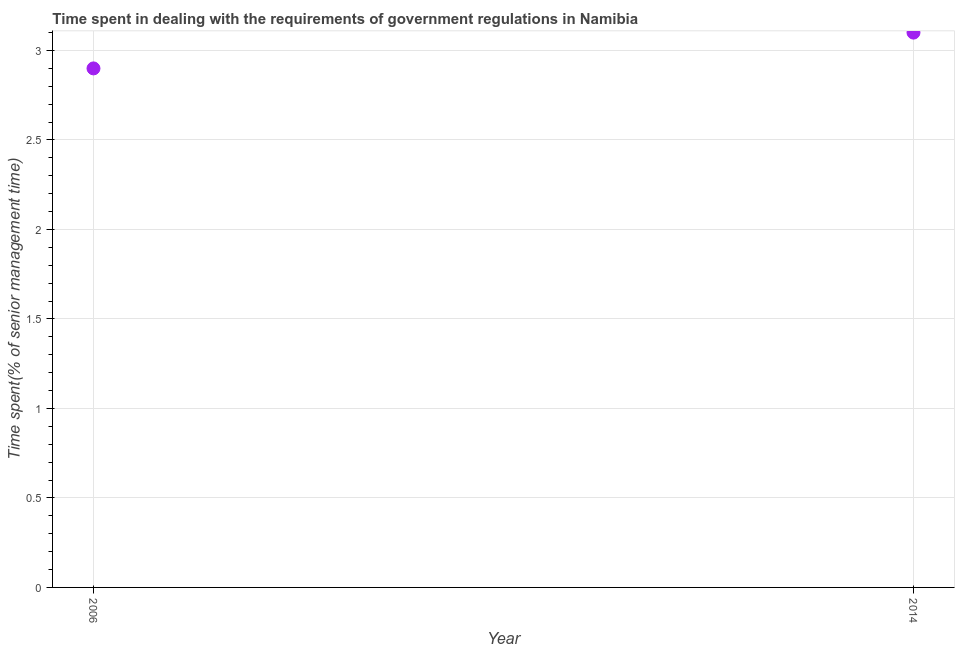What is the time spent in dealing with government regulations in 2014?
Provide a short and direct response. 3.1. In which year was the time spent in dealing with government regulations maximum?
Make the answer very short. 2014. What is the sum of the time spent in dealing with government regulations?
Provide a short and direct response. 6. What is the difference between the time spent in dealing with government regulations in 2006 and 2014?
Your answer should be very brief. -0.2. What is the median time spent in dealing with government regulations?
Offer a terse response. 3. Do a majority of the years between 2006 and 2014 (inclusive) have time spent in dealing with government regulations greater than 1.2 %?
Your answer should be compact. Yes. What is the ratio of the time spent in dealing with government regulations in 2006 to that in 2014?
Keep it short and to the point. 0.94. How many years are there in the graph?
Your answer should be very brief. 2. What is the difference between two consecutive major ticks on the Y-axis?
Your answer should be very brief. 0.5. Does the graph contain any zero values?
Make the answer very short. No. Does the graph contain grids?
Provide a succinct answer. Yes. What is the title of the graph?
Offer a very short reply. Time spent in dealing with the requirements of government regulations in Namibia. What is the label or title of the Y-axis?
Provide a short and direct response. Time spent(% of senior management time). What is the ratio of the Time spent(% of senior management time) in 2006 to that in 2014?
Your answer should be very brief. 0.94. 